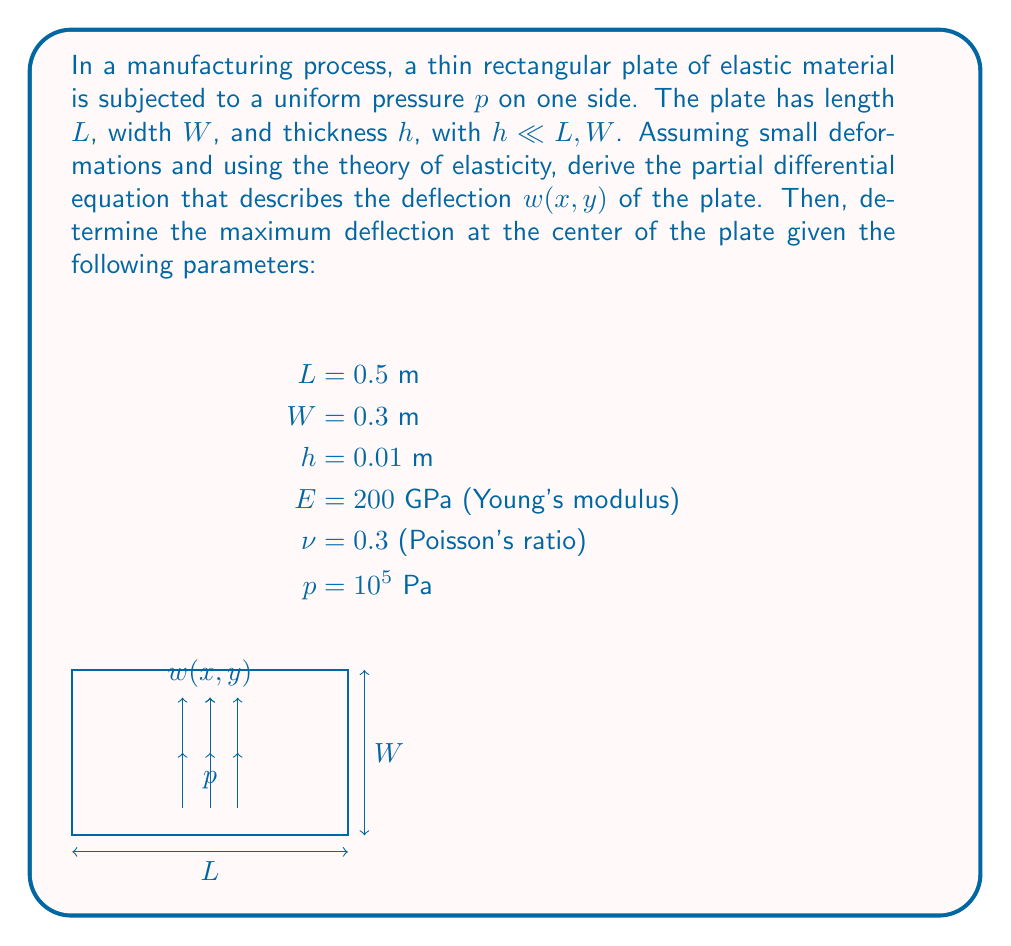Teach me how to tackle this problem. To solve this problem, we'll follow these steps:

1) First, we need to derive the governing partial differential equation for the plate deflection.
2) Then, we'll solve this equation for the maximum deflection at the center of the plate.

Step 1: Deriving the PDE

For a thin plate under small deformations, the deflection $w(x,y)$ is governed by the biharmonic equation:

$$\frac{\partial^4 w}{\partial x^4} + 2\frac{\partial^4 w}{\partial x^2\partial y^2} + \frac{\partial^4 w}{\partial y^4} = \frac{p}{D}$$

where $D$ is the flexural rigidity of the plate, given by:

$$D = \frac{Eh^3}{12(1-\nu^2)}$$

Step 2: Solving for maximum deflection

For a simply supported rectangular plate, the maximum deflection occurs at the center and is given by:

$$w_{max} = \alpha \frac{pL^4}{Eh^3}$$

where $\alpha$ is a coefficient that depends on the aspect ratio of the plate $(W/L)$. For $W/L = 0.6$, $\alpha \approx 0.00406$.

Now, let's calculate the maximum deflection:

$$w_{max} = 0.00406 \frac{(10^5)(0.5)^4}{(200 \times 10^9)(0.01)^3}$$

$$w_{max} = 0.00406 \frac{(10^5)(0.0625)}{(200 \times 10^9)(10^{-6})}$$

$$w_{max} = 0.00406 \frac{6250}{200000} = 1.27 \times 10^{-4} \text{ m}$$

Therefore, the maximum deflection at the center of the plate is approximately 0.127 mm.
Answer: The maximum deflection at the center of the plate is $1.27 \times 10^{-4}$ m or 0.127 mm. 